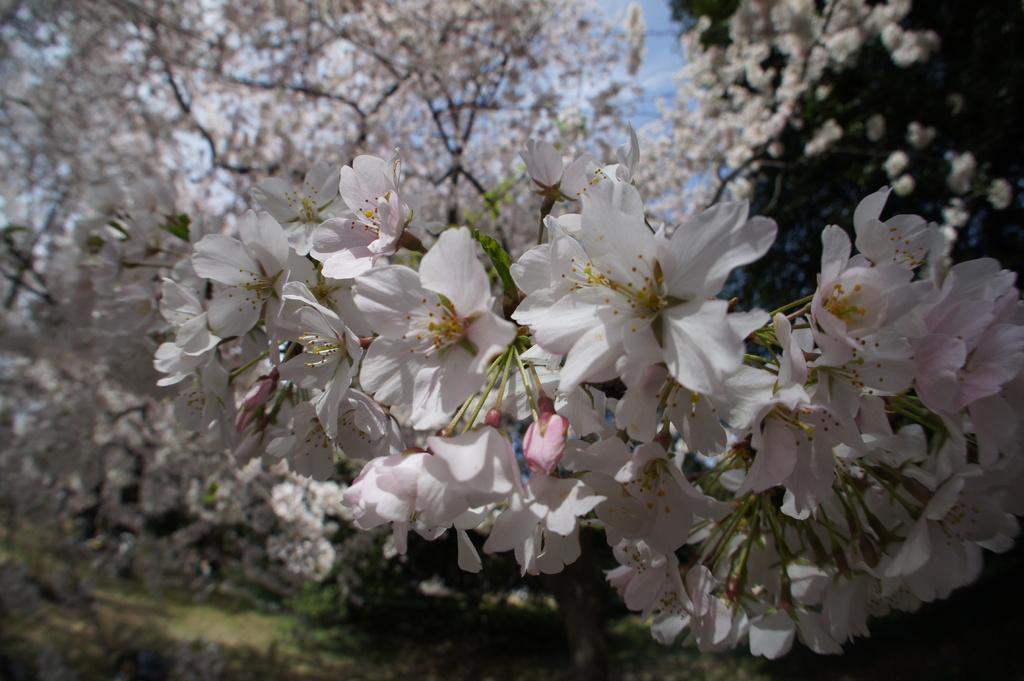What type of vegetation can be seen on the trees in the image? There are flowers on the trees in the image. What type of coach can be seen driving through the trees in the image? There is no coach present in the image; it only features flowers on the trees. What type of insect is sitting on the flowers in the image? There is no insect present in the image; it only features flowers on the trees. 